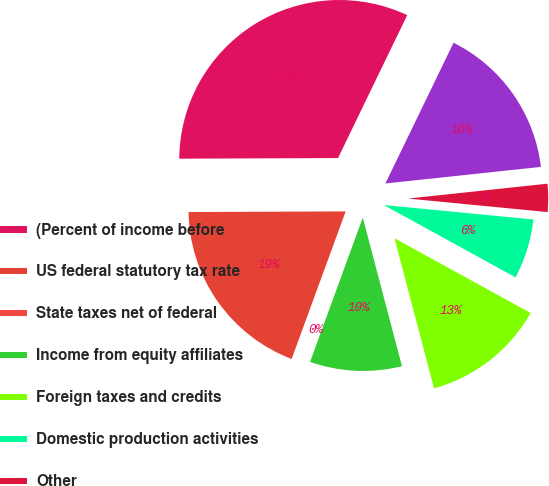<chart> <loc_0><loc_0><loc_500><loc_500><pie_chart><fcel>(Percent of income before<fcel>US federal statutory tax rate<fcel>State taxes net of federal<fcel>Income from equity affiliates<fcel>Foreign taxes and credits<fcel>Domestic production activities<fcel>Other<fcel>Effective Tax Rate<nl><fcel>32.24%<fcel>19.35%<fcel>0.01%<fcel>9.68%<fcel>12.9%<fcel>6.46%<fcel>3.23%<fcel>16.13%<nl></chart> 